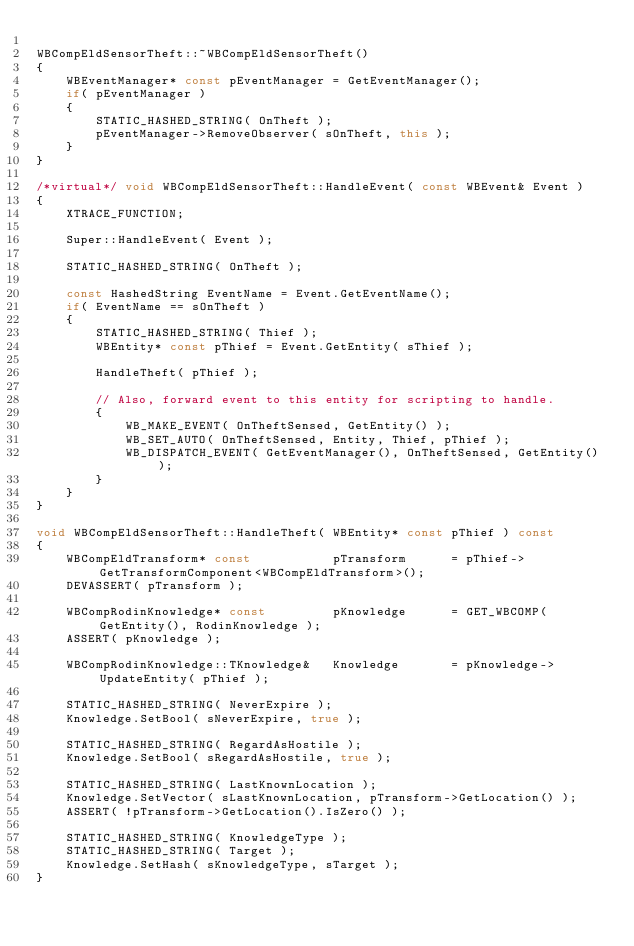<code> <loc_0><loc_0><loc_500><loc_500><_C++_>
WBCompEldSensorTheft::~WBCompEldSensorTheft()
{
	WBEventManager* const pEventManager = GetEventManager();
	if( pEventManager )
	{
		STATIC_HASHED_STRING( OnTheft );
		pEventManager->RemoveObserver( sOnTheft, this );
	}
}

/*virtual*/ void WBCompEldSensorTheft::HandleEvent( const WBEvent& Event )
{
	XTRACE_FUNCTION;

	Super::HandleEvent( Event );

	STATIC_HASHED_STRING( OnTheft );

	const HashedString EventName = Event.GetEventName();
	if( EventName == sOnTheft )
	{
		STATIC_HASHED_STRING( Thief );
		WBEntity* const pThief = Event.GetEntity( sThief );

		HandleTheft( pThief );

		// Also, forward event to this entity for scripting to handle.
		{
			WB_MAKE_EVENT( OnTheftSensed, GetEntity() );
			WB_SET_AUTO( OnTheftSensed, Entity, Thief, pThief );
			WB_DISPATCH_EVENT( GetEventManager(), OnTheftSensed, GetEntity() );
		}
	}
}

void WBCompEldSensorTheft::HandleTheft( WBEntity* const pThief ) const
{
	WBCompEldTransform* const			pTransform		= pThief->GetTransformComponent<WBCompEldTransform>();
	DEVASSERT( pTransform );

	WBCompRodinKnowledge* const			pKnowledge		= GET_WBCOMP( GetEntity(), RodinKnowledge );
	ASSERT( pKnowledge );

	WBCompRodinKnowledge::TKnowledge&	Knowledge		= pKnowledge->UpdateEntity( pThief );

	STATIC_HASHED_STRING( NeverExpire );
	Knowledge.SetBool( sNeverExpire, true );

	STATIC_HASHED_STRING( RegardAsHostile );
	Knowledge.SetBool( sRegardAsHostile, true );

	STATIC_HASHED_STRING( LastKnownLocation );
	Knowledge.SetVector( sLastKnownLocation, pTransform->GetLocation() );
	ASSERT( !pTransform->GetLocation().IsZero() );

	STATIC_HASHED_STRING( KnowledgeType );
	STATIC_HASHED_STRING( Target );
	Knowledge.SetHash( sKnowledgeType, sTarget );
}</code> 